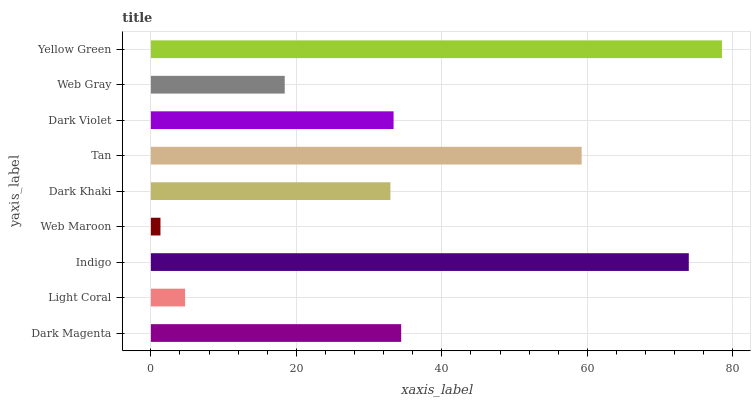Is Web Maroon the minimum?
Answer yes or no. Yes. Is Yellow Green the maximum?
Answer yes or no. Yes. Is Light Coral the minimum?
Answer yes or no. No. Is Light Coral the maximum?
Answer yes or no. No. Is Dark Magenta greater than Light Coral?
Answer yes or no. Yes. Is Light Coral less than Dark Magenta?
Answer yes or no. Yes. Is Light Coral greater than Dark Magenta?
Answer yes or no. No. Is Dark Magenta less than Light Coral?
Answer yes or no. No. Is Dark Violet the high median?
Answer yes or no. Yes. Is Dark Violet the low median?
Answer yes or no. Yes. Is Web Gray the high median?
Answer yes or no. No. Is Light Coral the low median?
Answer yes or no. No. 